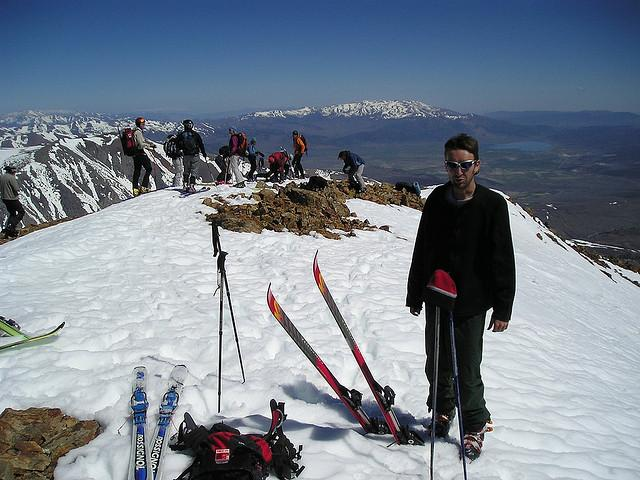How will everyone get off the top of the mountain? ski down 